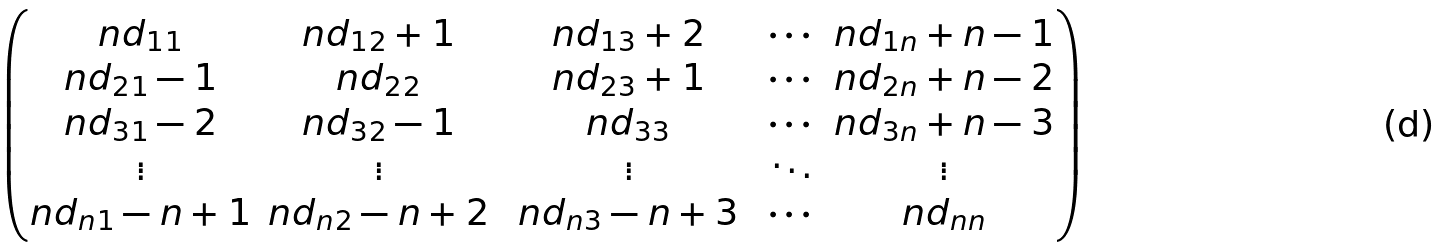Convert formula to latex. <formula><loc_0><loc_0><loc_500><loc_500>\begin{pmatrix} n d _ { 1 1 } & n d _ { 1 2 } + 1 & n d _ { 1 3 } + 2 & \cdots & n d _ { 1 n } + n - 1 \\ n d _ { 2 1 } - 1 & n d _ { 2 2 } & n d _ { 2 3 } + 1 & \cdots & n d _ { 2 n } + n - 2 \\ n d _ { 3 1 } - 2 & n d _ { 3 2 } - 1 & n d _ { 3 3 } & \cdots & n d _ { 3 n } + n - 3 \\ \vdots & \vdots & \vdots & \ddots & \vdots \\ n d _ { n 1 } - n + 1 & n d _ { n 2 } - n + 2 & \ n d _ { n 3 } - n + 3 \ & \cdots & n d _ { n n } \end{pmatrix}</formula> 